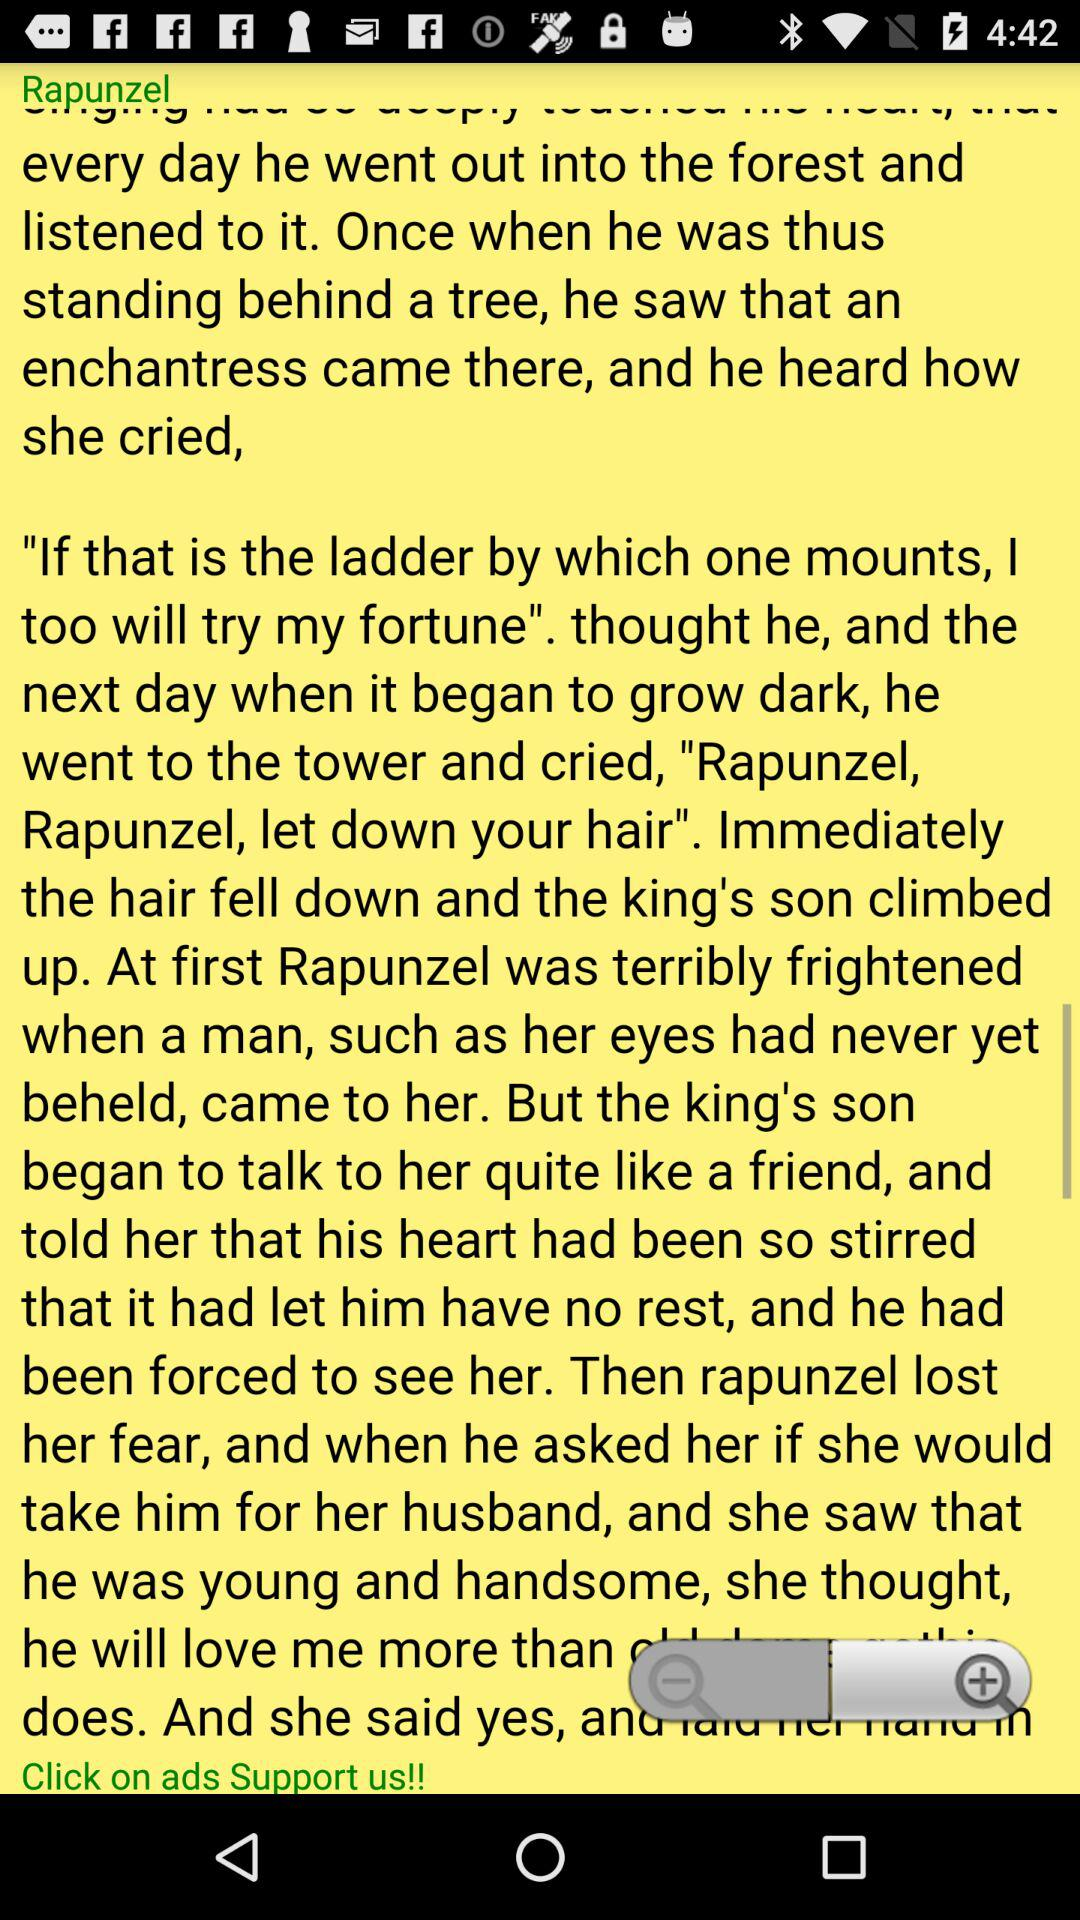How many magnifying glasses are there on the page?
Answer the question using a single word or phrase. 2 